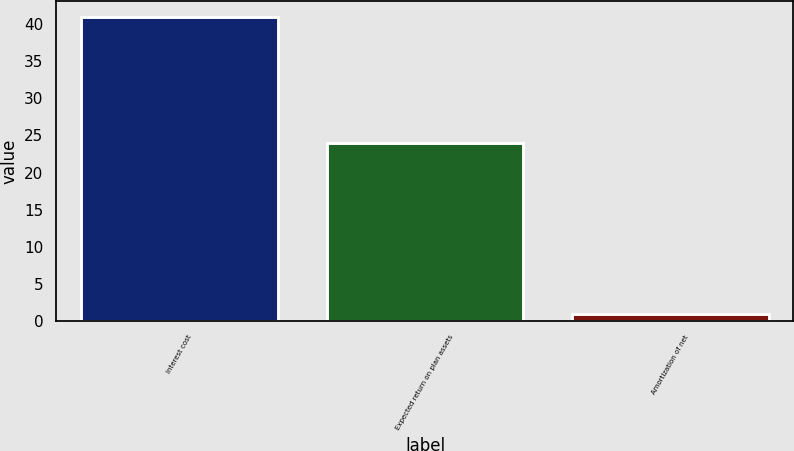Convert chart. <chart><loc_0><loc_0><loc_500><loc_500><bar_chart><fcel>Interest cost<fcel>Expected return on plan assets<fcel>Amortization of net<nl><fcel>41<fcel>24<fcel>1<nl></chart> 